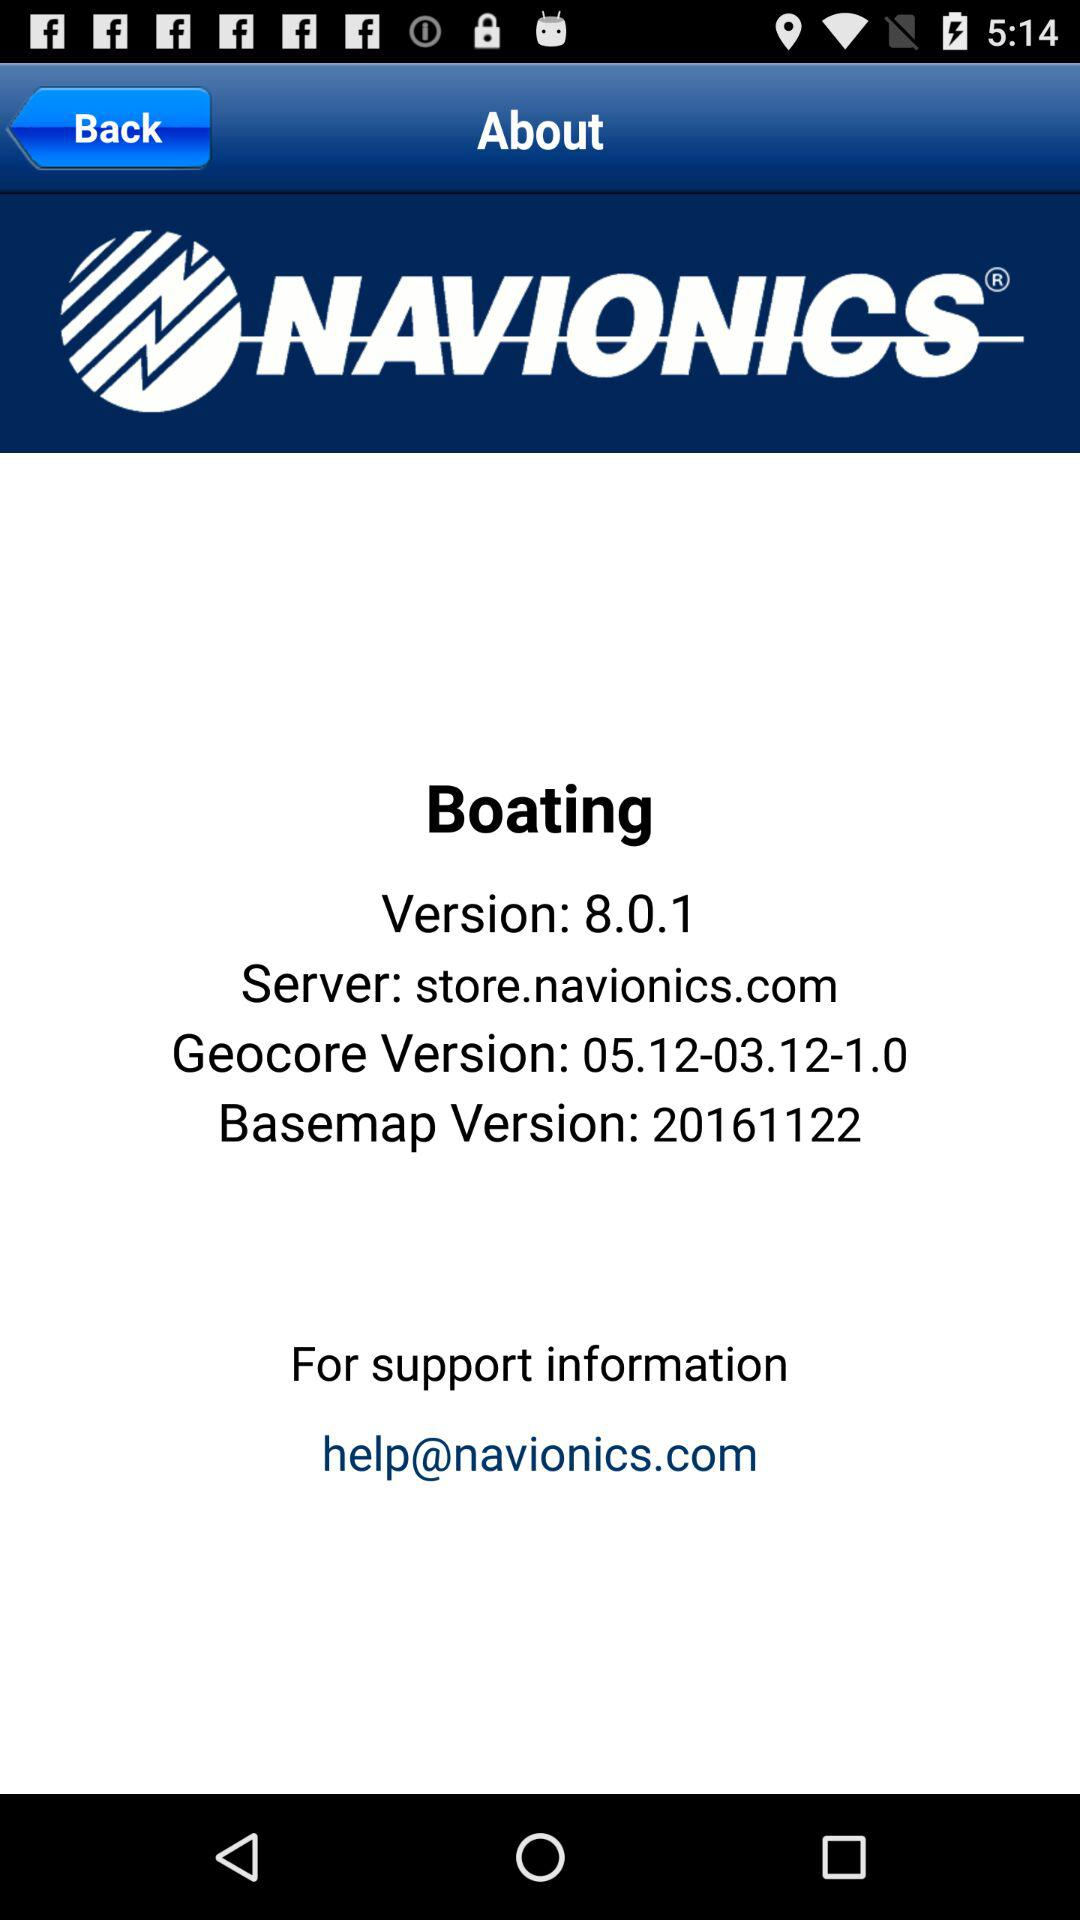How many version numbers are displayed?
Answer the question using a single word or phrase. 3 